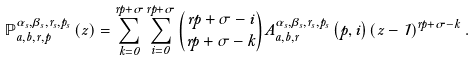<formula> <loc_0><loc_0><loc_500><loc_500>\mathbb { P } _ { a , b , r , p } ^ { \alpha _ { s } , \beta _ { s } , r _ { s } , p _ { s } } \left ( z \right ) = \sum _ { k = 0 } ^ { r p + \sigma } \sum _ { i = 0 } ^ { r p + \sigma } \binom { r p + \sigma - i } { r p + \sigma - k } A _ { a , b , r } ^ { \alpha _ { s } , \beta _ { s } , r _ { s } , p _ { s } } \left ( p , i \right ) \left ( z - 1 \right ) ^ { r p + \sigma - k } .</formula> 